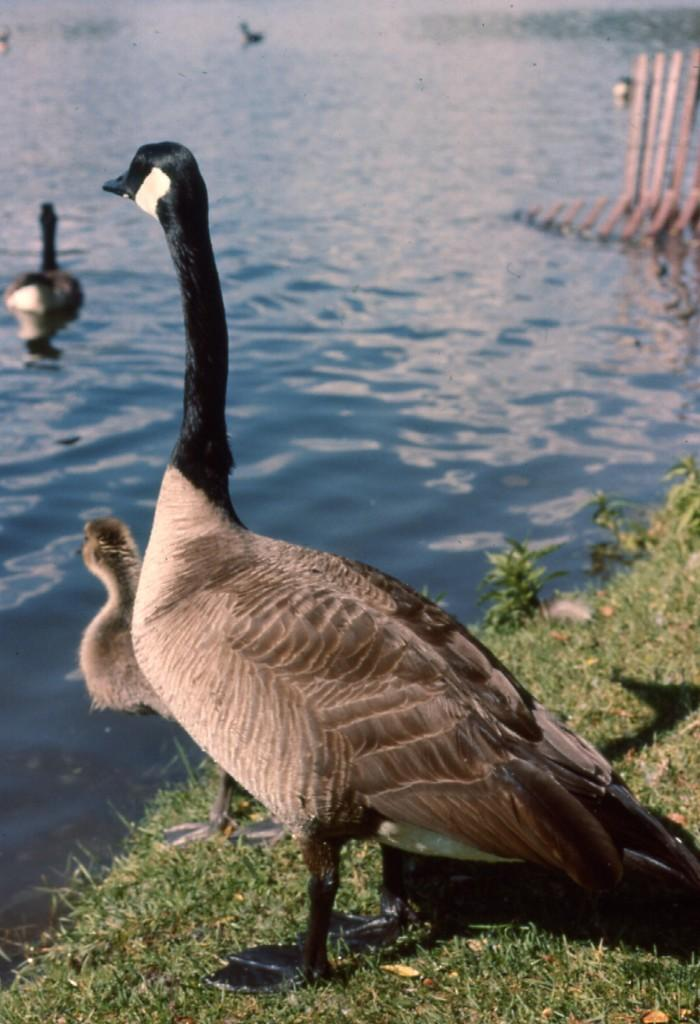What type of animals can be seen in the image? There are birds in the image. Where are some of the birds located? Some birds are on the water, and one bird is on the ground. What type of vegetation is present in the image? There are plants and grass in the image. What material can be seen in the image? There are wooden sticks in the image. What degree of difficulty is the bird on the ground attempting in the image? There is no indication of difficulty or any task being attempted by the bird in the image. --- 